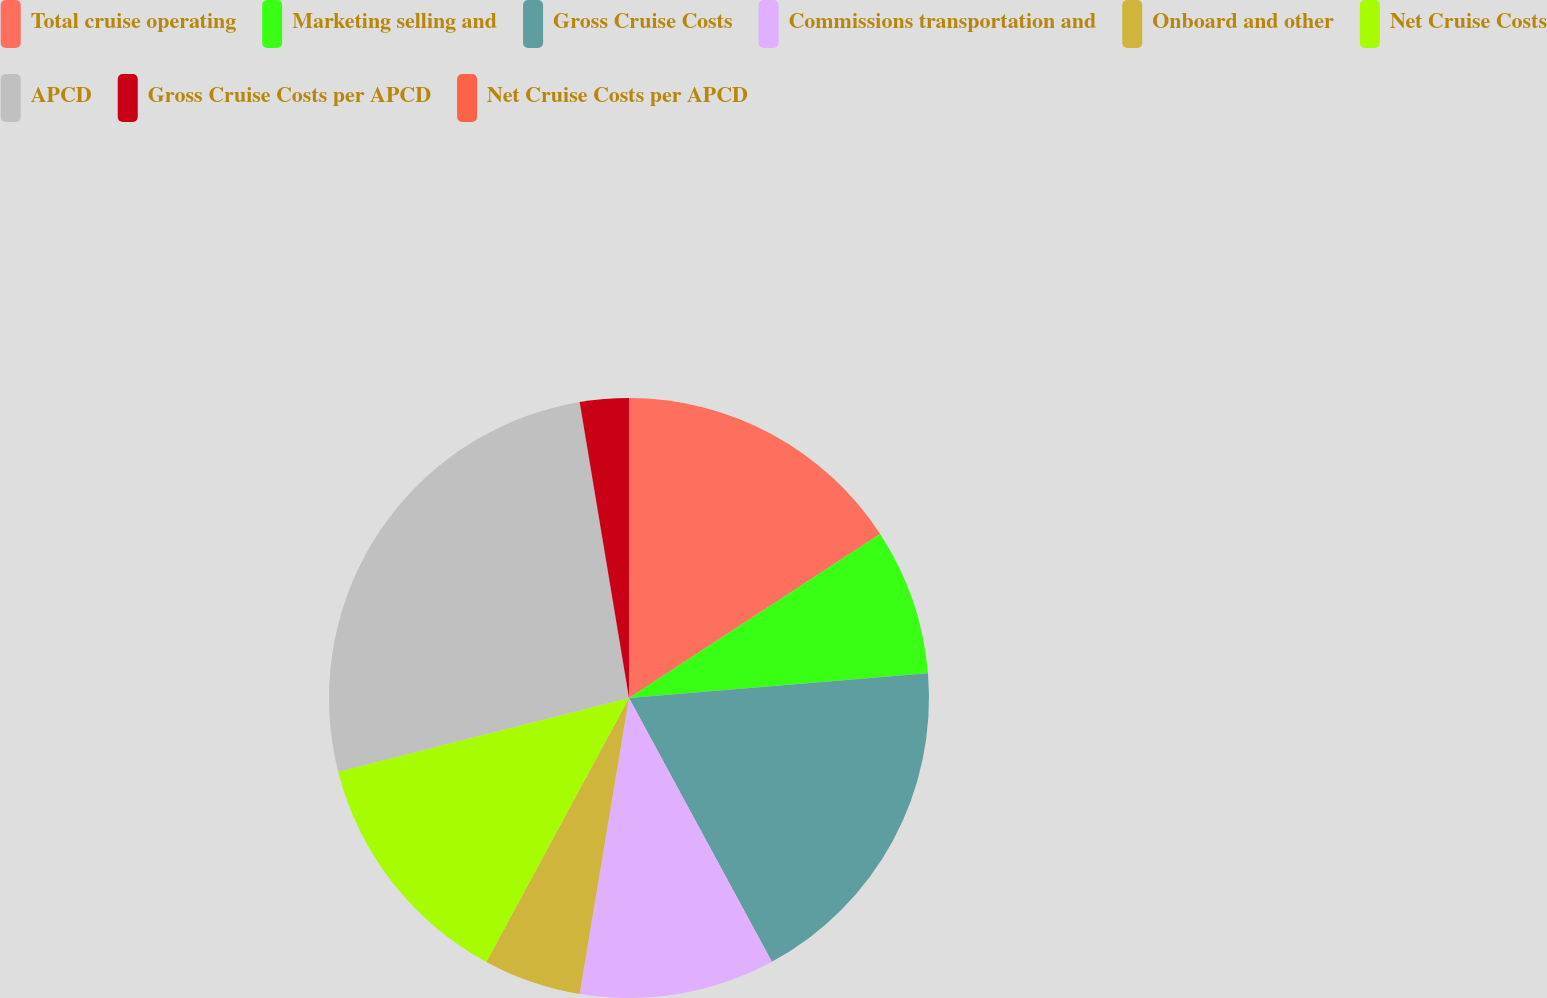<chart> <loc_0><loc_0><loc_500><loc_500><pie_chart><fcel>Total cruise operating<fcel>Marketing selling and<fcel>Gross Cruise Costs<fcel>Commissions transportation and<fcel>Onboard and other<fcel>Net Cruise Costs<fcel>APCD<fcel>Gross Cruise Costs per APCD<fcel>Net Cruise Costs per APCD<nl><fcel>15.79%<fcel>7.89%<fcel>18.42%<fcel>10.53%<fcel>5.26%<fcel>13.16%<fcel>26.32%<fcel>2.63%<fcel>0.0%<nl></chart> 